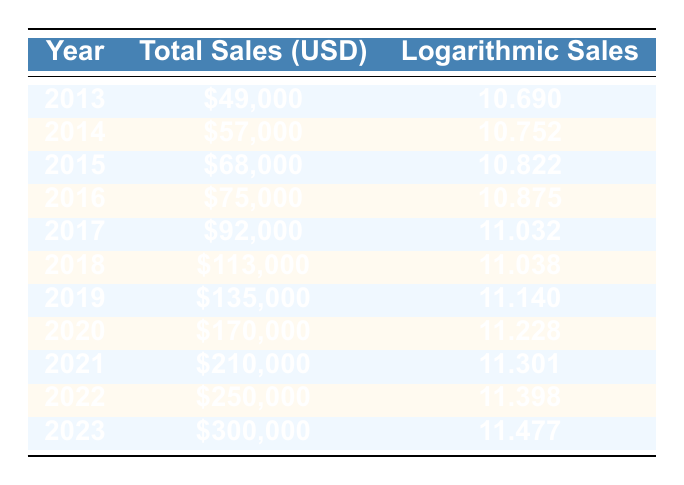What was the total sales in 2015? The total sales for 2015 is explicitly listed in the table under the "Total Sales (USD)" column for that year. It shows a value of \$68,000.
Answer: 68000 What year had the highest total sales? The table allows us to compare the total sales across all years listed. The year with the highest total sales is 2023, which has \$300,000.
Answer: 2023 What is the difference in total sales between 2013 and 2018? The total sales for 2013 is \$49,000 and for 2018 it is \$113,000. To find the difference, subtract the 2013 sales from the 2018 sales: \$113,000 - \$49,000 = \$64,000.
Answer: 64000 Is the logarithmic sales value for 2020 greater than for 2019? The logarithmic sales for 2020 is 11.228 and for 2019 it is 11.140. By comparing these two values, we can confirm that 11.228 is greater than 11.140, hence the statement is true.
Answer: Yes What is the average logarithmic sales value from 2013 to 2023? To find the average, we should sum the logarithmic sales values from all the years listed (10.690 + 10.752 + 10.822 + 10.875 + 11.032 + 11.038 + 11.140 + 11.228 + 11.301 + 11.398 + 11.477), which totals 122.049. Dividing by the number of years, which is 11: 122.049 / 11 = 11.095.
Answer: 11.095 What was the percentage increase in total sales from 2016 to 2017? The total sales in 2016 is \$75,000 and in 2017 is \$92,000. To find the percentage increase, subtract the earlier value from the later one (\$92,000 - \$75,000 = \$17,000), then divide by the earlier value and multiply by 100: (17,000 / 75,000) * 100 = 22.67%.
Answer: 22.67% 